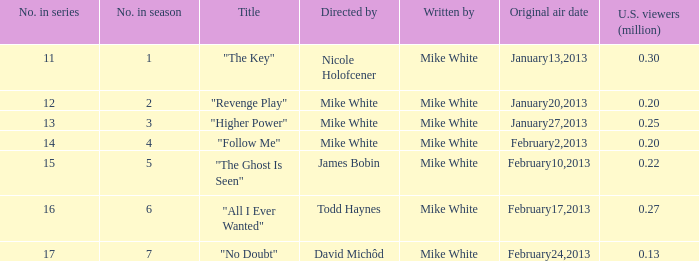What is the name of the episode directed by james bobin "The Ghost Is Seen". 